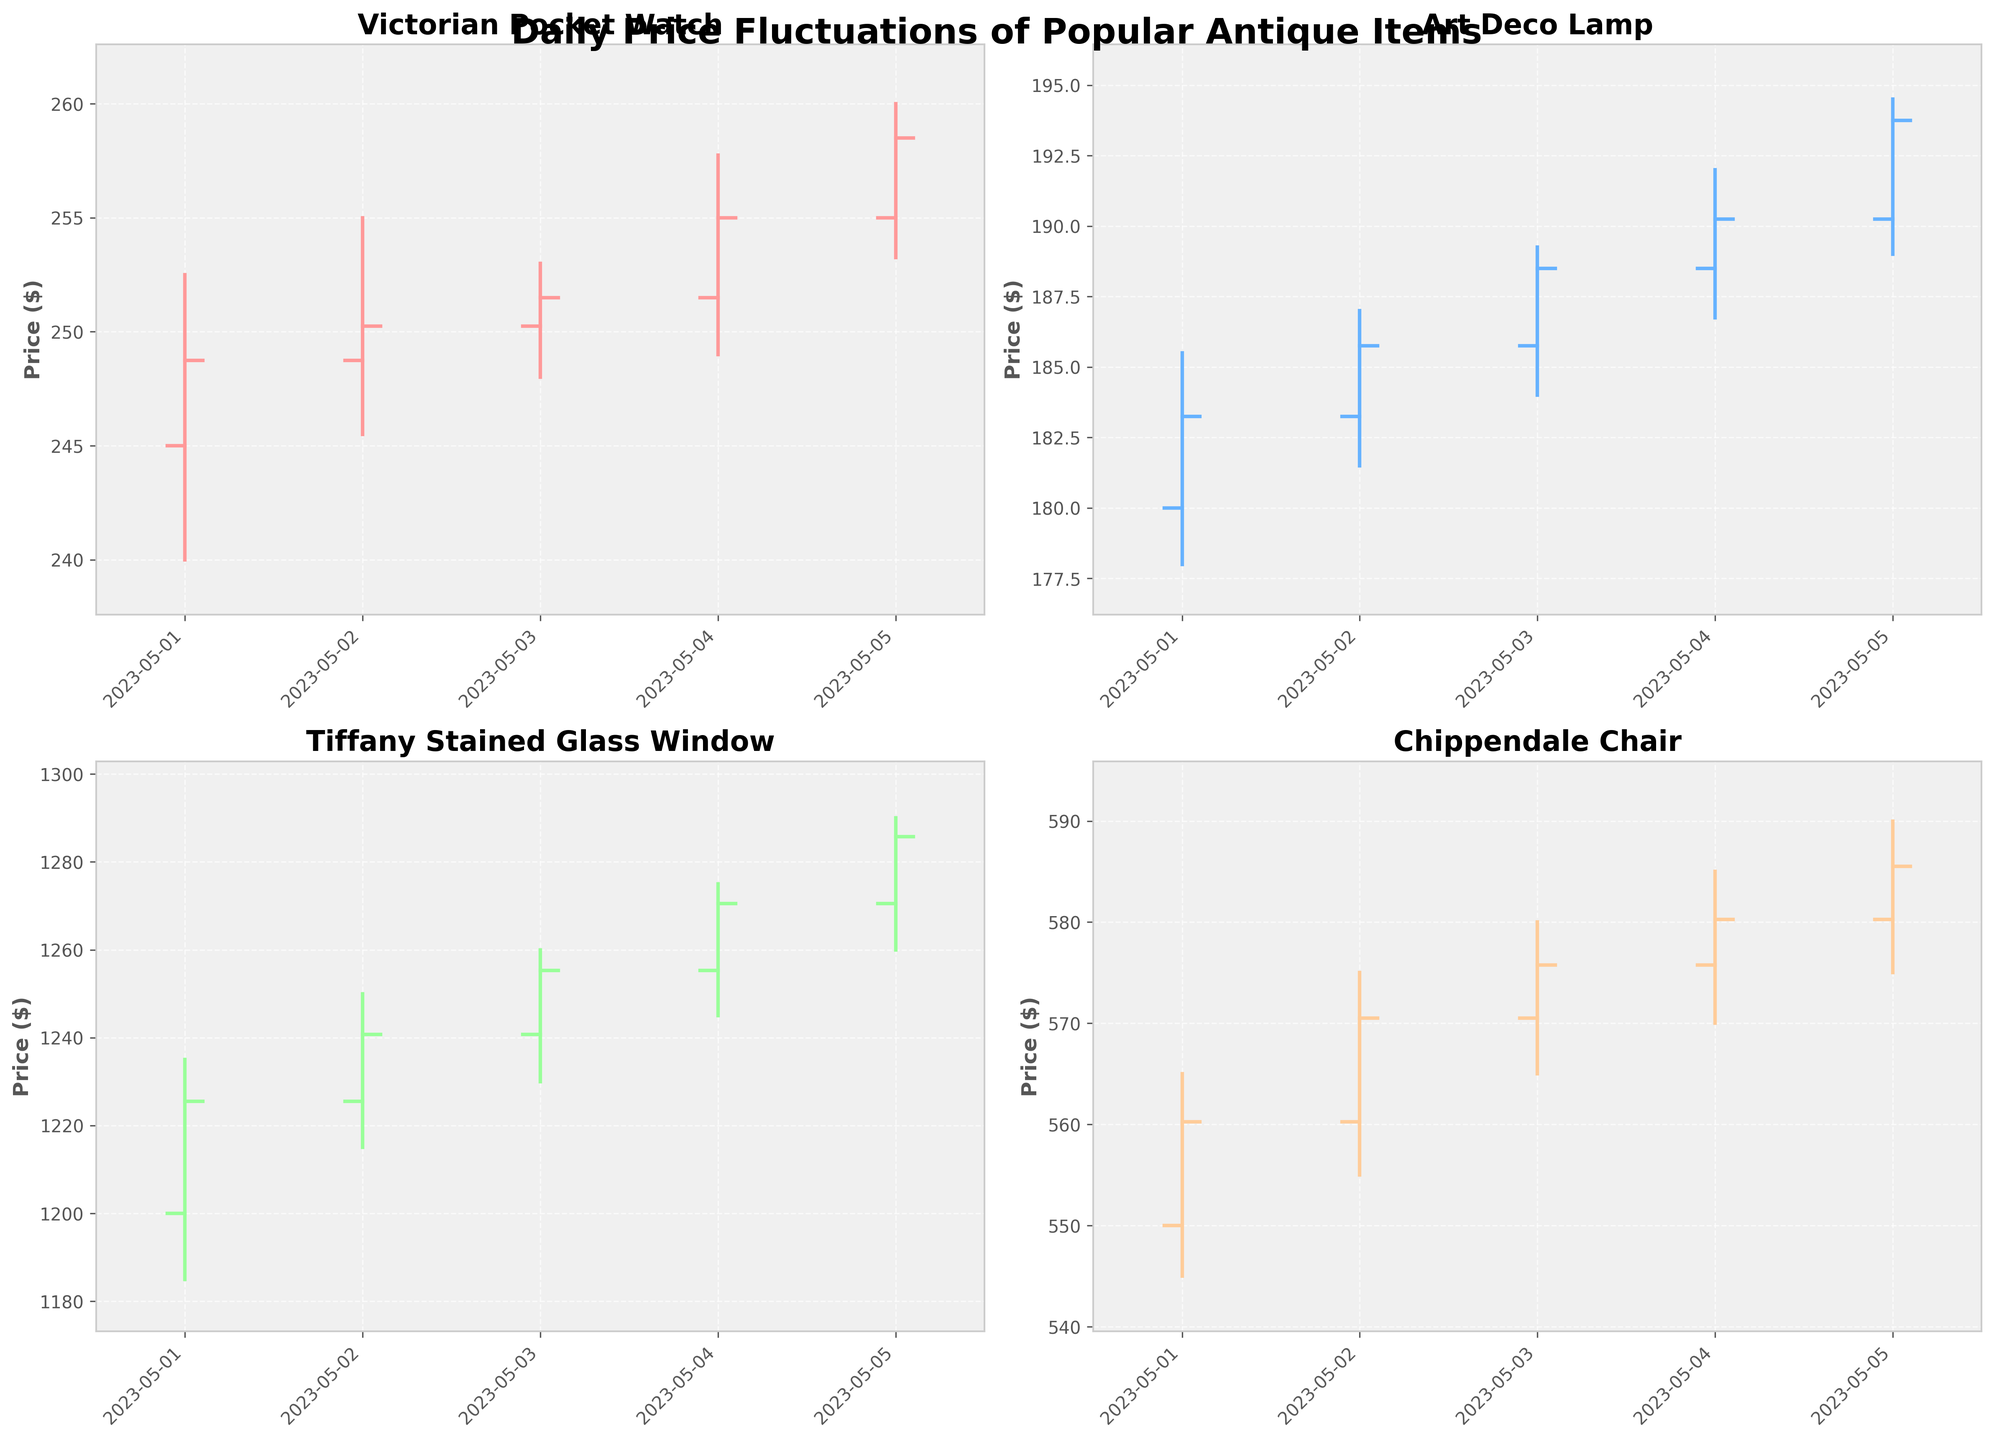What is the main title of the figure? The main title is usually placed at the top-center of the figure's layout, and in this case, it would be clearly displayed.
Answer: Daily Price Fluctuations of Popular Antique Items Which item shows the highest price on May 3rd? To determine the highest price on May 3rd, we need to compare the "High" values of all items on that day. By examining the highs, we see that the Tiffany Stained Glass Window has the highest value on May 3rd at $1260.00.
Answer: Tiffany Stained Glass Window How does the price of the Chippendale Chair change from the opening to closing on May 4th? For the Chippendale Chair on May 4th, the opening price can be observed at $575.75 and the closing price at $580.25. By subtracting the opening price from the closing price (580.25 - 575.75), we see a price increase of $4.50.
Answer: Increase by $4.50 Which Antique Item had the most significant price drop within a single day? The most significant price drop is determined by the difference between the High and Low prices on the same day. The data indicates that the Tiffany Stained Glass Window had the most significant drop on May 1st, decreasing from $1235.00 to $1185.00, a drop of $50.00.
Answer: Tiffany Stained Glass Window What is the general trend of the Art Deco Lamp prices over the five-day period? To determine the trend, observe the general movement of the closing prices for the Art Deco Lamp from May 1 to May 5, which are gradually increasing from $183.25 to $193.75.
Answer: Increasing Which item had the lowest closing price on any day, and what was that price? To find the lowest closing price, we need to look at the "Close" column of each item for each day. The lowest closing price observed is for the Tiffany Stained Glass Window on May 1st at $1225.50.
Answer: Tiffany Stained Glass Window, $1225.50 Compare the price range (High-Low) of the Victorian Pocket Watch on May 2nd with the Art Deco Lamp on the same day. Which one has a greater range? For May 2nd, the Victorian Pocket Watch has a price range of $255.00 - $245.50 = $9.50 and the Art Deco Lamp has a price range of $187.00 - $181.50 = $5.50. Comparing these, the Victorian Pocket Watch has a greater range of $9.50.
Answer: Victorian Pocket Watch What is the average closing price of the Tiffany Stained Glass Window over the five-day period? To calculate the average, add up all the closing prices for the Tiffany Stained Glass Window from May 1 to May 5: ($1225.50 + $1240.75 + $1255.25 + $1270.50 + $1285.75) = $6277.75. Then, divide by 5: $6277.75 / 5 ≈ $1255.55
Answer: $1255.55 What is the color used to represent each item, and how does it aid in distinguishing them? The colors listed in the code ('#FF9999', '#66B2FF', '#99FF99', '#FFCC99') are used to represent different items: Victorian Pocket Watch, Art Deco Lamp, Tiffany Stained Glass Window, Chippendale Chair. These distinct colors help viewers quickly differentiate between the items in the subplots.
Answer: Different colors for each item help in distinguishing: Victorian Pocket Watch (red), Art Deco Lamp (blue), Tiffany Stained Glass Window (green), Chippendale Chair (orange) 